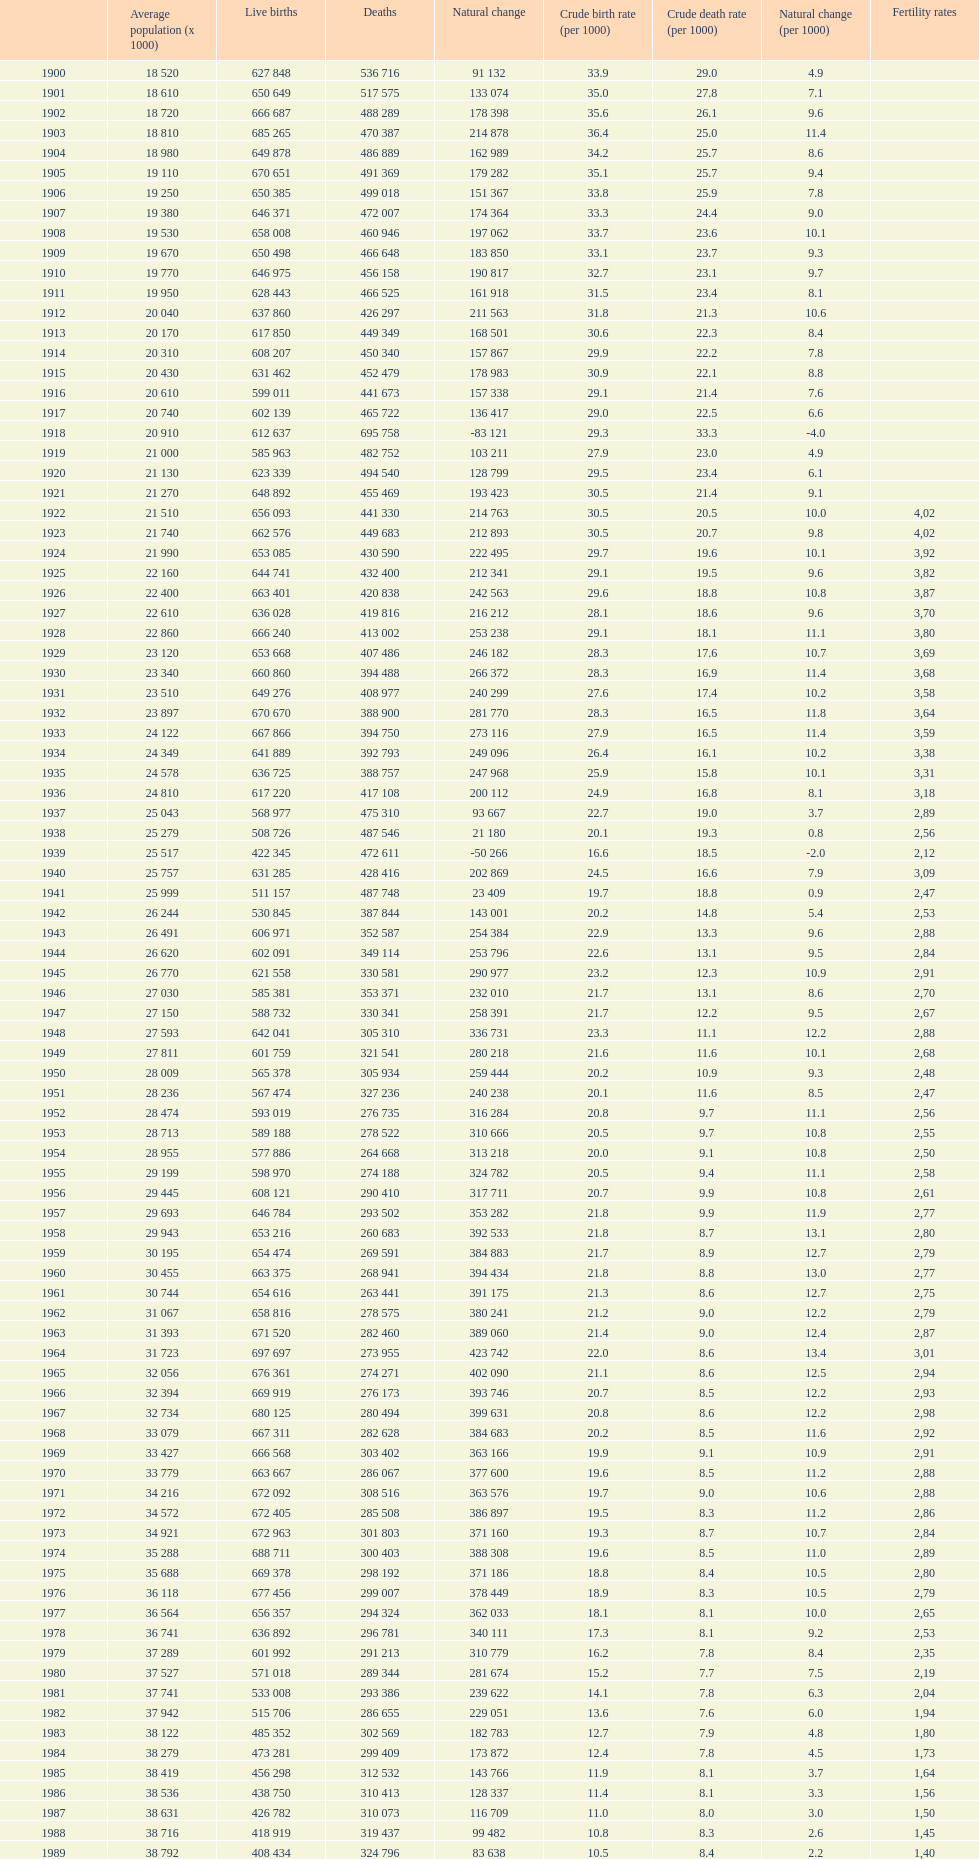1 for a population size of 22,860? 1928. 